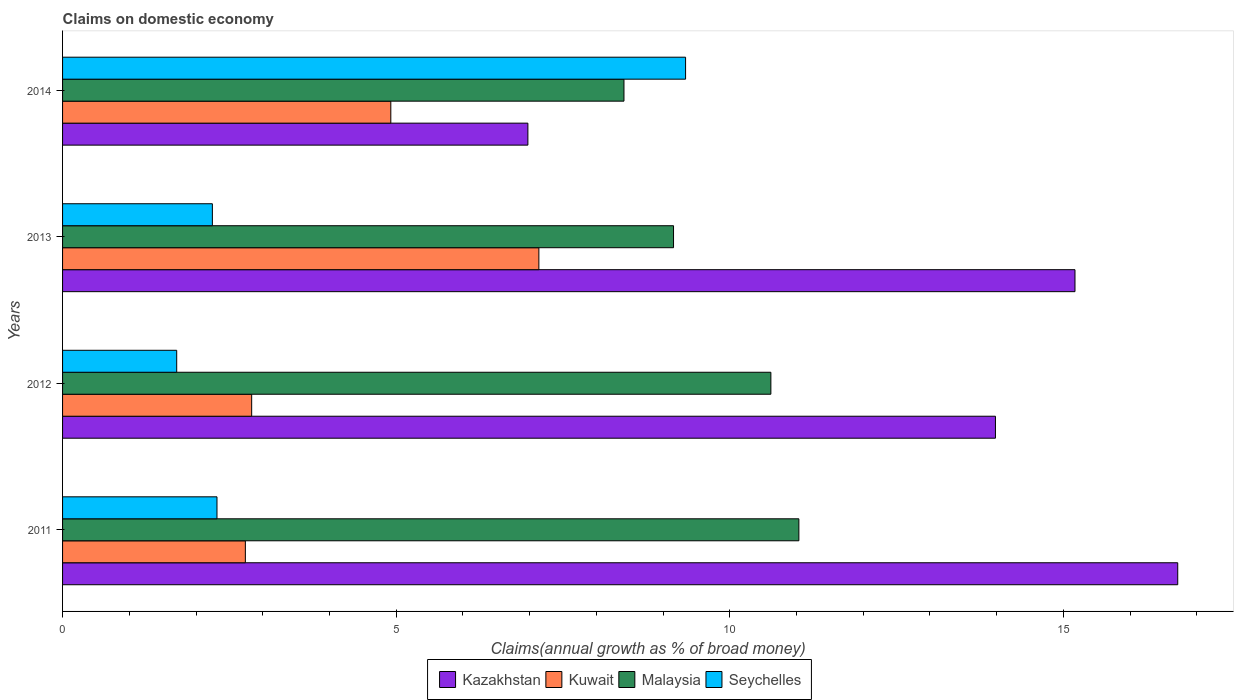How many different coloured bars are there?
Ensure brevity in your answer.  4. Are the number of bars per tick equal to the number of legend labels?
Offer a very short reply. Yes. What is the label of the 3rd group of bars from the top?
Give a very brief answer. 2012. In how many cases, is the number of bars for a given year not equal to the number of legend labels?
Make the answer very short. 0. What is the percentage of broad money claimed on domestic economy in Kuwait in 2011?
Make the answer very short. 2.74. Across all years, what is the maximum percentage of broad money claimed on domestic economy in Kazakhstan?
Give a very brief answer. 16.71. Across all years, what is the minimum percentage of broad money claimed on domestic economy in Malaysia?
Keep it short and to the point. 8.41. In which year was the percentage of broad money claimed on domestic economy in Seychelles maximum?
Provide a short and direct response. 2014. In which year was the percentage of broad money claimed on domestic economy in Malaysia minimum?
Your answer should be very brief. 2014. What is the total percentage of broad money claimed on domestic economy in Kuwait in the graph?
Ensure brevity in your answer.  17.63. What is the difference between the percentage of broad money claimed on domestic economy in Malaysia in 2011 and that in 2014?
Keep it short and to the point. 2.62. What is the difference between the percentage of broad money claimed on domestic economy in Kuwait in 2013 and the percentage of broad money claimed on domestic economy in Seychelles in 2012?
Keep it short and to the point. 5.43. What is the average percentage of broad money claimed on domestic economy in Malaysia per year?
Your response must be concise. 9.81. In the year 2014, what is the difference between the percentage of broad money claimed on domestic economy in Kazakhstan and percentage of broad money claimed on domestic economy in Malaysia?
Your answer should be compact. -1.44. What is the ratio of the percentage of broad money claimed on domestic economy in Malaysia in 2012 to that in 2014?
Your response must be concise. 1.26. Is the difference between the percentage of broad money claimed on domestic economy in Kazakhstan in 2012 and 2013 greater than the difference between the percentage of broad money claimed on domestic economy in Malaysia in 2012 and 2013?
Give a very brief answer. No. What is the difference between the highest and the second highest percentage of broad money claimed on domestic economy in Kuwait?
Provide a short and direct response. 2.22. What is the difference between the highest and the lowest percentage of broad money claimed on domestic economy in Malaysia?
Make the answer very short. 2.62. Is the sum of the percentage of broad money claimed on domestic economy in Kazakhstan in 2011 and 2013 greater than the maximum percentage of broad money claimed on domestic economy in Kuwait across all years?
Ensure brevity in your answer.  Yes. Is it the case that in every year, the sum of the percentage of broad money claimed on domestic economy in Malaysia and percentage of broad money claimed on domestic economy in Seychelles is greater than the sum of percentage of broad money claimed on domestic economy in Kazakhstan and percentage of broad money claimed on domestic economy in Kuwait?
Make the answer very short. No. What does the 4th bar from the top in 2014 represents?
Keep it short and to the point. Kazakhstan. What does the 1st bar from the bottom in 2011 represents?
Give a very brief answer. Kazakhstan. How many bars are there?
Keep it short and to the point. 16. Are all the bars in the graph horizontal?
Provide a succinct answer. Yes. How many years are there in the graph?
Provide a succinct answer. 4. What is the difference between two consecutive major ticks on the X-axis?
Your answer should be very brief. 5. How many legend labels are there?
Your response must be concise. 4. What is the title of the graph?
Your answer should be compact. Claims on domestic economy. Does "Philippines" appear as one of the legend labels in the graph?
Provide a succinct answer. No. What is the label or title of the X-axis?
Your response must be concise. Claims(annual growth as % of broad money). What is the label or title of the Y-axis?
Give a very brief answer. Years. What is the Claims(annual growth as % of broad money) of Kazakhstan in 2011?
Your answer should be very brief. 16.71. What is the Claims(annual growth as % of broad money) in Kuwait in 2011?
Make the answer very short. 2.74. What is the Claims(annual growth as % of broad money) of Malaysia in 2011?
Provide a succinct answer. 11.04. What is the Claims(annual growth as % of broad money) in Seychelles in 2011?
Offer a terse response. 2.31. What is the Claims(annual growth as % of broad money) of Kazakhstan in 2012?
Your answer should be very brief. 13.98. What is the Claims(annual growth as % of broad money) in Kuwait in 2012?
Ensure brevity in your answer.  2.83. What is the Claims(annual growth as % of broad money) in Malaysia in 2012?
Ensure brevity in your answer.  10.62. What is the Claims(annual growth as % of broad money) in Seychelles in 2012?
Provide a short and direct response. 1.71. What is the Claims(annual growth as % of broad money) in Kazakhstan in 2013?
Your response must be concise. 15.17. What is the Claims(annual growth as % of broad money) of Kuwait in 2013?
Offer a very short reply. 7.14. What is the Claims(annual growth as % of broad money) in Malaysia in 2013?
Provide a succinct answer. 9.16. What is the Claims(annual growth as % of broad money) of Seychelles in 2013?
Provide a short and direct response. 2.25. What is the Claims(annual growth as % of broad money) of Kazakhstan in 2014?
Give a very brief answer. 6.97. What is the Claims(annual growth as % of broad money) in Kuwait in 2014?
Provide a succinct answer. 4.92. What is the Claims(annual growth as % of broad money) of Malaysia in 2014?
Offer a terse response. 8.41. What is the Claims(annual growth as % of broad money) of Seychelles in 2014?
Your answer should be very brief. 9.34. Across all years, what is the maximum Claims(annual growth as % of broad money) in Kazakhstan?
Provide a succinct answer. 16.71. Across all years, what is the maximum Claims(annual growth as % of broad money) of Kuwait?
Offer a very short reply. 7.14. Across all years, what is the maximum Claims(annual growth as % of broad money) in Malaysia?
Offer a terse response. 11.04. Across all years, what is the maximum Claims(annual growth as % of broad money) in Seychelles?
Make the answer very short. 9.34. Across all years, what is the minimum Claims(annual growth as % of broad money) in Kazakhstan?
Keep it short and to the point. 6.97. Across all years, what is the minimum Claims(annual growth as % of broad money) of Kuwait?
Your answer should be very brief. 2.74. Across all years, what is the minimum Claims(annual growth as % of broad money) of Malaysia?
Provide a short and direct response. 8.41. Across all years, what is the minimum Claims(annual growth as % of broad money) in Seychelles?
Your answer should be very brief. 1.71. What is the total Claims(annual growth as % of broad money) of Kazakhstan in the graph?
Your answer should be very brief. 52.84. What is the total Claims(annual growth as % of broad money) of Kuwait in the graph?
Your response must be concise. 17.63. What is the total Claims(annual growth as % of broad money) of Malaysia in the graph?
Your response must be concise. 39.22. What is the total Claims(annual growth as % of broad money) of Seychelles in the graph?
Provide a succinct answer. 15.61. What is the difference between the Claims(annual growth as % of broad money) in Kazakhstan in 2011 and that in 2012?
Your answer should be compact. 2.73. What is the difference between the Claims(annual growth as % of broad money) in Kuwait in 2011 and that in 2012?
Offer a terse response. -0.09. What is the difference between the Claims(annual growth as % of broad money) of Malaysia in 2011 and that in 2012?
Offer a very short reply. 0.42. What is the difference between the Claims(annual growth as % of broad money) of Seychelles in 2011 and that in 2012?
Provide a succinct answer. 0.6. What is the difference between the Claims(annual growth as % of broad money) in Kazakhstan in 2011 and that in 2013?
Your answer should be compact. 1.54. What is the difference between the Claims(annual growth as % of broad money) in Kuwait in 2011 and that in 2013?
Ensure brevity in your answer.  -4.4. What is the difference between the Claims(annual growth as % of broad money) of Malaysia in 2011 and that in 2013?
Ensure brevity in your answer.  1.88. What is the difference between the Claims(annual growth as % of broad money) in Seychelles in 2011 and that in 2013?
Your answer should be very brief. 0.07. What is the difference between the Claims(annual growth as % of broad money) in Kazakhstan in 2011 and that in 2014?
Give a very brief answer. 9.74. What is the difference between the Claims(annual growth as % of broad money) of Kuwait in 2011 and that in 2014?
Your answer should be very brief. -2.18. What is the difference between the Claims(annual growth as % of broad money) in Malaysia in 2011 and that in 2014?
Provide a succinct answer. 2.62. What is the difference between the Claims(annual growth as % of broad money) of Seychelles in 2011 and that in 2014?
Make the answer very short. -7.02. What is the difference between the Claims(annual growth as % of broad money) in Kazakhstan in 2012 and that in 2013?
Offer a very short reply. -1.19. What is the difference between the Claims(annual growth as % of broad money) of Kuwait in 2012 and that in 2013?
Your response must be concise. -4.3. What is the difference between the Claims(annual growth as % of broad money) in Malaysia in 2012 and that in 2013?
Ensure brevity in your answer.  1.46. What is the difference between the Claims(annual growth as % of broad money) of Seychelles in 2012 and that in 2013?
Offer a very short reply. -0.53. What is the difference between the Claims(annual growth as % of broad money) of Kazakhstan in 2012 and that in 2014?
Keep it short and to the point. 7.01. What is the difference between the Claims(annual growth as % of broad money) in Kuwait in 2012 and that in 2014?
Keep it short and to the point. -2.09. What is the difference between the Claims(annual growth as % of broad money) of Malaysia in 2012 and that in 2014?
Your response must be concise. 2.2. What is the difference between the Claims(annual growth as % of broad money) in Seychelles in 2012 and that in 2014?
Offer a very short reply. -7.63. What is the difference between the Claims(annual growth as % of broad money) in Kazakhstan in 2013 and that in 2014?
Provide a succinct answer. 8.2. What is the difference between the Claims(annual growth as % of broad money) of Kuwait in 2013 and that in 2014?
Keep it short and to the point. 2.22. What is the difference between the Claims(annual growth as % of broad money) of Malaysia in 2013 and that in 2014?
Your answer should be compact. 0.74. What is the difference between the Claims(annual growth as % of broad money) of Seychelles in 2013 and that in 2014?
Make the answer very short. -7.09. What is the difference between the Claims(annual growth as % of broad money) of Kazakhstan in 2011 and the Claims(annual growth as % of broad money) of Kuwait in 2012?
Make the answer very short. 13.88. What is the difference between the Claims(annual growth as % of broad money) in Kazakhstan in 2011 and the Claims(annual growth as % of broad money) in Malaysia in 2012?
Provide a short and direct response. 6.1. What is the difference between the Claims(annual growth as % of broad money) of Kazakhstan in 2011 and the Claims(annual growth as % of broad money) of Seychelles in 2012?
Offer a terse response. 15. What is the difference between the Claims(annual growth as % of broad money) of Kuwait in 2011 and the Claims(annual growth as % of broad money) of Malaysia in 2012?
Offer a terse response. -7.88. What is the difference between the Claims(annual growth as % of broad money) of Malaysia in 2011 and the Claims(annual growth as % of broad money) of Seychelles in 2012?
Offer a terse response. 9.32. What is the difference between the Claims(annual growth as % of broad money) of Kazakhstan in 2011 and the Claims(annual growth as % of broad money) of Kuwait in 2013?
Your response must be concise. 9.58. What is the difference between the Claims(annual growth as % of broad money) of Kazakhstan in 2011 and the Claims(annual growth as % of broad money) of Malaysia in 2013?
Provide a short and direct response. 7.56. What is the difference between the Claims(annual growth as % of broad money) of Kazakhstan in 2011 and the Claims(annual growth as % of broad money) of Seychelles in 2013?
Keep it short and to the point. 14.47. What is the difference between the Claims(annual growth as % of broad money) in Kuwait in 2011 and the Claims(annual growth as % of broad money) in Malaysia in 2013?
Offer a terse response. -6.42. What is the difference between the Claims(annual growth as % of broad money) in Kuwait in 2011 and the Claims(annual growth as % of broad money) in Seychelles in 2013?
Provide a succinct answer. 0.49. What is the difference between the Claims(annual growth as % of broad money) of Malaysia in 2011 and the Claims(annual growth as % of broad money) of Seychelles in 2013?
Provide a short and direct response. 8.79. What is the difference between the Claims(annual growth as % of broad money) of Kazakhstan in 2011 and the Claims(annual growth as % of broad money) of Kuwait in 2014?
Your response must be concise. 11.79. What is the difference between the Claims(annual growth as % of broad money) in Kazakhstan in 2011 and the Claims(annual growth as % of broad money) in Malaysia in 2014?
Keep it short and to the point. 8.3. What is the difference between the Claims(annual growth as % of broad money) of Kazakhstan in 2011 and the Claims(annual growth as % of broad money) of Seychelles in 2014?
Your answer should be compact. 7.38. What is the difference between the Claims(annual growth as % of broad money) in Kuwait in 2011 and the Claims(annual growth as % of broad money) in Malaysia in 2014?
Keep it short and to the point. -5.67. What is the difference between the Claims(annual growth as % of broad money) in Kuwait in 2011 and the Claims(annual growth as % of broad money) in Seychelles in 2014?
Make the answer very short. -6.6. What is the difference between the Claims(annual growth as % of broad money) of Malaysia in 2011 and the Claims(annual growth as % of broad money) of Seychelles in 2014?
Your answer should be very brief. 1.7. What is the difference between the Claims(annual growth as % of broad money) in Kazakhstan in 2012 and the Claims(annual growth as % of broad money) in Kuwait in 2013?
Your answer should be very brief. 6.84. What is the difference between the Claims(annual growth as % of broad money) in Kazakhstan in 2012 and the Claims(annual growth as % of broad money) in Malaysia in 2013?
Provide a succinct answer. 4.83. What is the difference between the Claims(annual growth as % of broad money) in Kazakhstan in 2012 and the Claims(annual growth as % of broad money) in Seychelles in 2013?
Offer a very short reply. 11.74. What is the difference between the Claims(annual growth as % of broad money) of Kuwait in 2012 and the Claims(annual growth as % of broad money) of Malaysia in 2013?
Your response must be concise. -6.32. What is the difference between the Claims(annual growth as % of broad money) of Kuwait in 2012 and the Claims(annual growth as % of broad money) of Seychelles in 2013?
Provide a short and direct response. 0.59. What is the difference between the Claims(annual growth as % of broad money) of Malaysia in 2012 and the Claims(annual growth as % of broad money) of Seychelles in 2013?
Your response must be concise. 8.37. What is the difference between the Claims(annual growth as % of broad money) of Kazakhstan in 2012 and the Claims(annual growth as % of broad money) of Kuwait in 2014?
Your answer should be very brief. 9.06. What is the difference between the Claims(annual growth as % of broad money) in Kazakhstan in 2012 and the Claims(annual growth as % of broad money) in Malaysia in 2014?
Your answer should be compact. 5.57. What is the difference between the Claims(annual growth as % of broad money) in Kazakhstan in 2012 and the Claims(annual growth as % of broad money) in Seychelles in 2014?
Your response must be concise. 4.64. What is the difference between the Claims(annual growth as % of broad money) in Kuwait in 2012 and the Claims(annual growth as % of broad money) in Malaysia in 2014?
Offer a terse response. -5.58. What is the difference between the Claims(annual growth as % of broad money) in Kuwait in 2012 and the Claims(annual growth as % of broad money) in Seychelles in 2014?
Offer a very short reply. -6.5. What is the difference between the Claims(annual growth as % of broad money) in Malaysia in 2012 and the Claims(annual growth as % of broad money) in Seychelles in 2014?
Offer a very short reply. 1.28. What is the difference between the Claims(annual growth as % of broad money) of Kazakhstan in 2013 and the Claims(annual growth as % of broad money) of Kuwait in 2014?
Your answer should be compact. 10.25. What is the difference between the Claims(annual growth as % of broad money) in Kazakhstan in 2013 and the Claims(annual growth as % of broad money) in Malaysia in 2014?
Keep it short and to the point. 6.76. What is the difference between the Claims(annual growth as % of broad money) in Kazakhstan in 2013 and the Claims(annual growth as % of broad money) in Seychelles in 2014?
Ensure brevity in your answer.  5.84. What is the difference between the Claims(annual growth as % of broad money) in Kuwait in 2013 and the Claims(annual growth as % of broad money) in Malaysia in 2014?
Keep it short and to the point. -1.28. What is the difference between the Claims(annual growth as % of broad money) of Kuwait in 2013 and the Claims(annual growth as % of broad money) of Seychelles in 2014?
Provide a short and direct response. -2.2. What is the difference between the Claims(annual growth as % of broad money) of Malaysia in 2013 and the Claims(annual growth as % of broad money) of Seychelles in 2014?
Your answer should be very brief. -0.18. What is the average Claims(annual growth as % of broad money) of Kazakhstan per year?
Ensure brevity in your answer.  13.21. What is the average Claims(annual growth as % of broad money) of Kuwait per year?
Give a very brief answer. 4.41. What is the average Claims(annual growth as % of broad money) in Malaysia per year?
Ensure brevity in your answer.  9.81. What is the average Claims(annual growth as % of broad money) of Seychelles per year?
Your answer should be very brief. 3.9. In the year 2011, what is the difference between the Claims(annual growth as % of broad money) in Kazakhstan and Claims(annual growth as % of broad money) in Kuwait?
Your response must be concise. 13.97. In the year 2011, what is the difference between the Claims(annual growth as % of broad money) in Kazakhstan and Claims(annual growth as % of broad money) in Malaysia?
Provide a short and direct response. 5.68. In the year 2011, what is the difference between the Claims(annual growth as % of broad money) of Kazakhstan and Claims(annual growth as % of broad money) of Seychelles?
Provide a succinct answer. 14.4. In the year 2011, what is the difference between the Claims(annual growth as % of broad money) of Kuwait and Claims(annual growth as % of broad money) of Malaysia?
Offer a terse response. -8.3. In the year 2011, what is the difference between the Claims(annual growth as % of broad money) of Kuwait and Claims(annual growth as % of broad money) of Seychelles?
Keep it short and to the point. 0.43. In the year 2011, what is the difference between the Claims(annual growth as % of broad money) of Malaysia and Claims(annual growth as % of broad money) of Seychelles?
Offer a very short reply. 8.72. In the year 2012, what is the difference between the Claims(annual growth as % of broad money) in Kazakhstan and Claims(annual growth as % of broad money) in Kuwait?
Your answer should be compact. 11.15. In the year 2012, what is the difference between the Claims(annual growth as % of broad money) in Kazakhstan and Claims(annual growth as % of broad money) in Malaysia?
Your answer should be very brief. 3.37. In the year 2012, what is the difference between the Claims(annual growth as % of broad money) in Kazakhstan and Claims(annual growth as % of broad money) in Seychelles?
Make the answer very short. 12.27. In the year 2012, what is the difference between the Claims(annual growth as % of broad money) of Kuwait and Claims(annual growth as % of broad money) of Malaysia?
Give a very brief answer. -7.78. In the year 2012, what is the difference between the Claims(annual growth as % of broad money) of Kuwait and Claims(annual growth as % of broad money) of Seychelles?
Your answer should be compact. 1.12. In the year 2012, what is the difference between the Claims(annual growth as % of broad money) in Malaysia and Claims(annual growth as % of broad money) in Seychelles?
Keep it short and to the point. 8.91. In the year 2013, what is the difference between the Claims(annual growth as % of broad money) in Kazakhstan and Claims(annual growth as % of broad money) in Kuwait?
Ensure brevity in your answer.  8.04. In the year 2013, what is the difference between the Claims(annual growth as % of broad money) of Kazakhstan and Claims(annual growth as % of broad money) of Malaysia?
Your answer should be compact. 6.02. In the year 2013, what is the difference between the Claims(annual growth as % of broad money) of Kazakhstan and Claims(annual growth as % of broad money) of Seychelles?
Offer a terse response. 12.93. In the year 2013, what is the difference between the Claims(annual growth as % of broad money) in Kuwait and Claims(annual growth as % of broad money) in Malaysia?
Provide a short and direct response. -2.02. In the year 2013, what is the difference between the Claims(annual growth as % of broad money) of Kuwait and Claims(annual growth as % of broad money) of Seychelles?
Offer a terse response. 4.89. In the year 2013, what is the difference between the Claims(annual growth as % of broad money) in Malaysia and Claims(annual growth as % of broad money) in Seychelles?
Provide a short and direct response. 6.91. In the year 2014, what is the difference between the Claims(annual growth as % of broad money) in Kazakhstan and Claims(annual growth as % of broad money) in Kuwait?
Offer a terse response. 2.05. In the year 2014, what is the difference between the Claims(annual growth as % of broad money) in Kazakhstan and Claims(annual growth as % of broad money) in Malaysia?
Your response must be concise. -1.44. In the year 2014, what is the difference between the Claims(annual growth as % of broad money) in Kazakhstan and Claims(annual growth as % of broad money) in Seychelles?
Give a very brief answer. -2.36. In the year 2014, what is the difference between the Claims(annual growth as % of broad money) of Kuwait and Claims(annual growth as % of broad money) of Malaysia?
Keep it short and to the point. -3.49. In the year 2014, what is the difference between the Claims(annual growth as % of broad money) of Kuwait and Claims(annual growth as % of broad money) of Seychelles?
Provide a short and direct response. -4.42. In the year 2014, what is the difference between the Claims(annual growth as % of broad money) in Malaysia and Claims(annual growth as % of broad money) in Seychelles?
Ensure brevity in your answer.  -0.92. What is the ratio of the Claims(annual growth as % of broad money) of Kazakhstan in 2011 to that in 2012?
Your response must be concise. 1.2. What is the ratio of the Claims(annual growth as % of broad money) in Kuwait in 2011 to that in 2012?
Keep it short and to the point. 0.97. What is the ratio of the Claims(annual growth as % of broad money) in Malaysia in 2011 to that in 2012?
Offer a terse response. 1.04. What is the ratio of the Claims(annual growth as % of broad money) in Seychelles in 2011 to that in 2012?
Your response must be concise. 1.35. What is the ratio of the Claims(annual growth as % of broad money) of Kazakhstan in 2011 to that in 2013?
Offer a very short reply. 1.1. What is the ratio of the Claims(annual growth as % of broad money) in Kuwait in 2011 to that in 2013?
Keep it short and to the point. 0.38. What is the ratio of the Claims(annual growth as % of broad money) of Malaysia in 2011 to that in 2013?
Your answer should be compact. 1.21. What is the ratio of the Claims(annual growth as % of broad money) of Seychelles in 2011 to that in 2013?
Provide a succinct answer. 1.03. What is the ratio of the Claims(annual growth as % of broad money) of Kazakhstan in 2011 to that in 2014?
Your answer should be compact. 2.4. What is the ratio of the Claims(annual growth as % of broad money) in Kuwait in 2011 to that in 2014?
Offer a very short reply. 0.56. What is the ratio of the Claims(annual growth as % of broad money) in Malaysia in 2011 to that in 2014?
Offer a very short reply. 1.31. What is the ratio of the Claims(annual growth as % of broad money) in Seychelles in 2011 to that in 2014?
Provide a short and direct response. 0.25. What is the ratio of the Claims(annual growth as % of broad money) in Kazakhstan in 2012 to that in 2013?
Ensure brevity in your answer.  0.92. What is the ratio of the Claims(annual growth as % of broad money) in Kuwait in 2012 to that in 2013?
Keep it short and to the point. 0.4. What is the ratio of the Claims(annual growth as % of broad money) in Malaysia in 2012 to that in 2013?
Make the answer very short. 1.16. What is the ratio of the Claims(annual growth as % of broad money) of Seychelles in 2012 to that in 2013?
Provide a succinct answer. 0.76. What is the ratio of the Claims(annual growth as % of broad money) of Kazakhstan in 2012 to that in 2014?
Keep it short and to the point. 2. What is the ratio of the Claims(annual growth as % of broad money) in Kuwait in 2012 to that in 2014?
Provide a short and direct response. 0.58. What is the ratio of the Claims(annual growth as % of broad money) of Malaysia in 2012 to that in 2014?
Make the answer very short. 1.26. What is the ratio of the Claims(annual growth as % of broad money) of Seychelles in 2012 to that in 2014?
Provide a succinct answer. 0.18. What is the ratio of the Claims(annual growth as % of broad money) in Kazakhstan in 2013 to that in 2014?
Ensure brevity in your answer.  2.18. What is the ratio of the Claims(annual growth as % of broad money) of Kuwait in 2013 to that in 2014?
Provide a succinct answer. 1.45. What is the ratio of the Claims(annual growth as % of broad money) of Malaysia in 2013 to that in 2014?
Your answer should be very brief. 1.09. What is the ratio of the Claims(annual growth as % of broad money) in Seychelles in 2013 to that in 2014?
Give a very brief answer. 0.24. What is the difference between the highest and the second highest Claims(annual growth as % of broad money) in Kazakhstan?
Give a very brief answer. 1.54. What is the difference between the highest and the second highest Claims(annual growth as % of broad money) of Kuwait?
Make the answer very short. 2.22. What is the difference between the highest and the second highest Claims(annual growth as % of broad money) of Malaysia?
Offer a very short reply. 0.42. What is the difference between the highest and the second highest Claims(annual growth as % of broad money) in Seychelles?
Ensure brevity in your answer.  7.02. What is the difference between the highest and the lowest Claims(annual growth as % of broad money) in Kazakhstan?
Keep it short and to the point. 9.74. What is the difference between the highest and the lowest Claims(annual growth as % of broad money) in Kuwait?
Offer a very short reply. 4.4. What is the difference between the highest and the lowest Claims(annual growth as % of broad money) of Malaysia?
Your response must be concise. 2.62. What is the difference between the highest and the lowest Claims(annual growth as % of broad money) of Seychelles?
Your response must be concise. 7.63. 